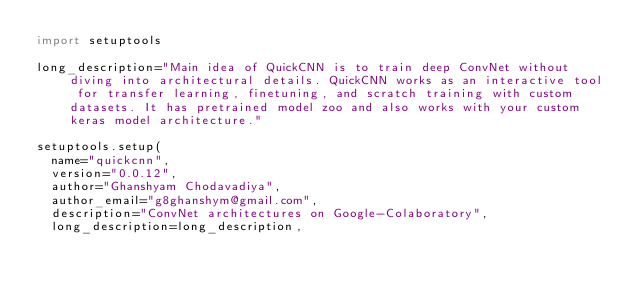Convert code to text. <code><loc_0><loc_0><loc_500><loc_500><_Python_>import setuptools

long_description="Main idea of QuickCNN is to train deep ConvNet without diving into architectural details. QuickCNN works as an interactive tool for transfer learning, finetuning, and scratch training with custom datasets. It has pretrained model zoo and also works with your custom keras model architecture."

setuptools.setup(
	name="quickcnn",
	version="0.0.12",
	author="Ghanshyam Chodavadiya",
	author_email="g8ghanshym@gmail.com",
	description="ConvNet architectures on Google-Colaboratory",
	long_description=long_description,</code> 